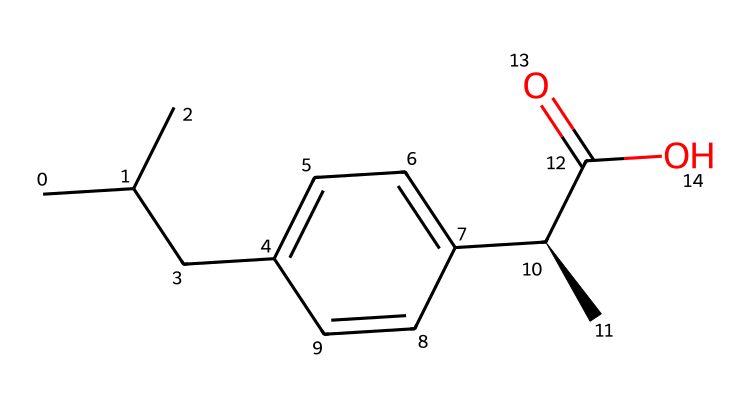What is the molecular formula of ibuprofen? To find the molecular formula, count the number of carbon (C), hydrogen (H), and oxygen (O) atoms in the structure based on the SMILES representation. The structure shows 13 carbon atoms, 18 hydrogen atoms, and 2 oxygen atoms, giving the molecular formula C13H18O2.
Answer: C13H18O2 How many stereocenters are present in ibuprofen? By analyzing the structure, we see that there is one chiral center indicated by the symbol “@” in the SMILES, which signifies the stereochemistry of that carbon atom. Thus, ibuprofen has one stereocenter.
Answer: 1 What type of functional group is characterized by the presence of the -C(=O)O portion in ibuprofen? The -C(=O)O portion indicates a carboxylic acid functional group where a carbon atom is double-bonded to an oxygen (carbonyl group) and single-bonded to a hydroxyl group (–OH). This defines it as a carboxylic acid.
Answer: carboxylic acid What is the significance of the isopropyl group in ibuprofen's structure? The isopropyl group (CC(C)) contributes to the hydrophobic character of ibuprofen, enhancing its ability to permeate cell membranes, thereby aiding its pharmacological activity.
Answer: hydrophobic character Which parts of the structure contribute to ibuprofen’s anti-inflammatory properties? The anti-inflammatory effects of ibuprofen are attributed to its ability to inhibit cyclooxygenase enzymes, which is facilitated by the presence of the carboxylic acid group that can participate in hydrogen bonding and stabilize binding interactions.
Answer: carboxylic acid group 